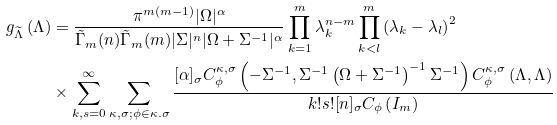Convert formula to latex. <formula><loc_0><loc_0><loc_500><loc_500>g _ { \widetilde { \Lambda } } \left ( { \Lambda } \right ) & = \frac { \pi ^ { m ( m - 1 ) } | \Omega | ^ { \alpha } } { \tilde { \Gamma } _ { m } ( n ) \tilde { \Gamma } _ { m } ( m ) | \Sigma | ^ { n } | \Omega + \Sigma ^ { - 1 } | ^ { \alpha } } \prod _ { k = 1 } ^ { m } { \lambda } _ { k } ^ { n - m } \prod _ { k < l } ^ { m } \left ( { \lambda } _ { k } - { \lambda } _ { l } \right ) ^ { 2 } \\ & \times \sum _ { k , s = 0 } ^ { \infty } \sum _ { \kappa , \sigma ; \phi \in \kappa . \sigma } \frac { [ \alpha ] _ { \sigma } C _ { \phi } ^ { \kappa , \sigma } \left ( - \Sigma ^ { - 1 } , \Sigma ^ { - 1 } \left ( \Omega + \Sigma ^ { - 1 } \right ) ^ { - 1 } \Sigma ^ { - 1 } \right ) C _ { \phi } ^ { \kappa , \sigma } \left ( { \Lambda } , { \Lambda } \right ) } { k ! s ! [ n ] _ { \sigma } C _ { \phi } \left ( I _ { m } \right ) }</formula> 